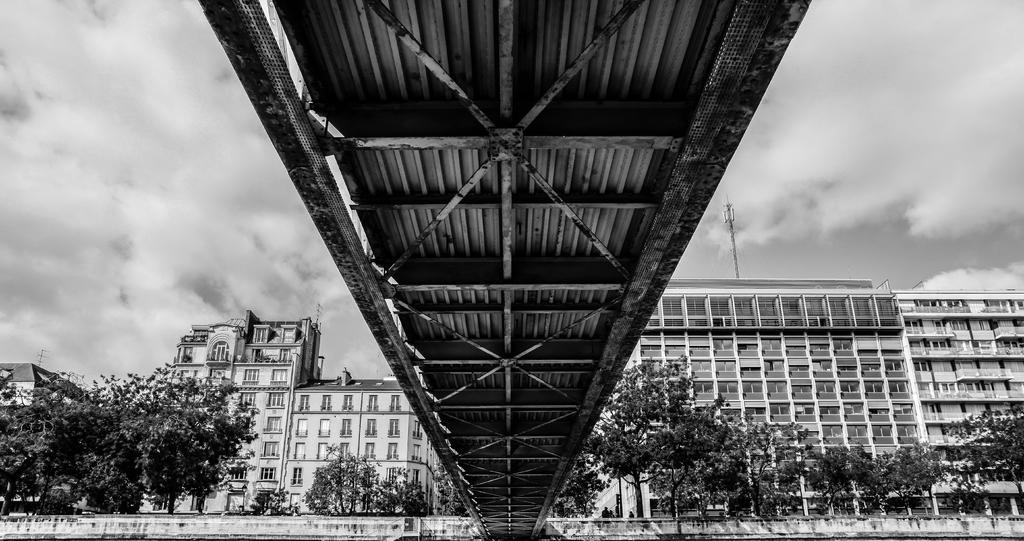What type of structures can be seen in the image? There are many buildings in the image. What feature do the buildings have? The buildings have windows. What type of natural elements are present in the image? There are many trees in the image. How would you describe the sky in the image? The sky is cloudy in the image. What other objects can be seen in the image? There is a pole and a bridge in the image. How much territory does the blood cover in the image? There is no blood present in the image, so it is not possible to determine the territory it covers. 